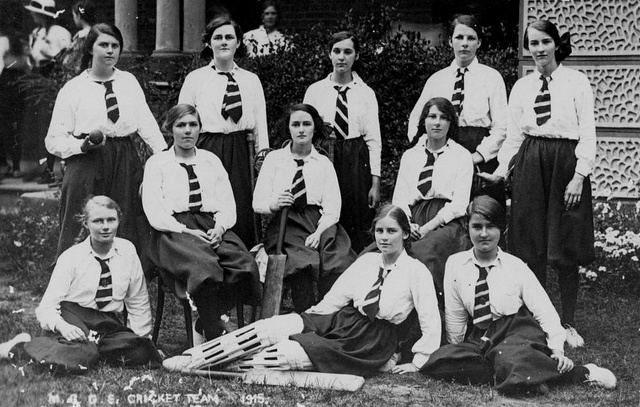Describe the objects in this image and their specific colors. I can see people in black, lightgray, gray, and darkgray tones, people in black, lightgray, darkgray, and gray tones, people in black, lightgray, gray, and darkgray tones, people in black, lightgray, gray, and darkgray tones, and people in black, lightgray, gray, and darkgray tones in this image. 